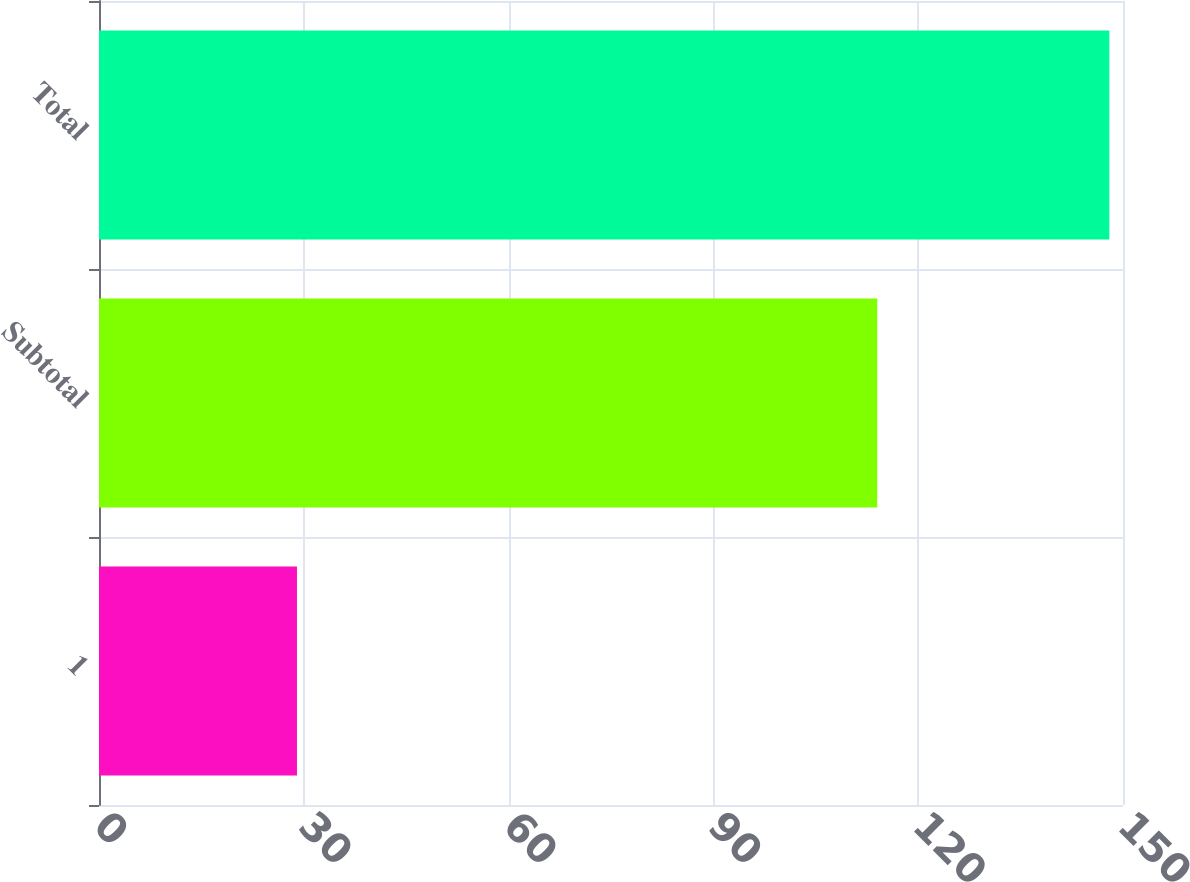Convert chart. <chart><loc_0><loc_0><loc_500><loc_500><bar_chart><fcel>1<fcel>Subtotal<fcel>Total<nl><fcel>29<fcel>114<fcel>148<nl></chart> 